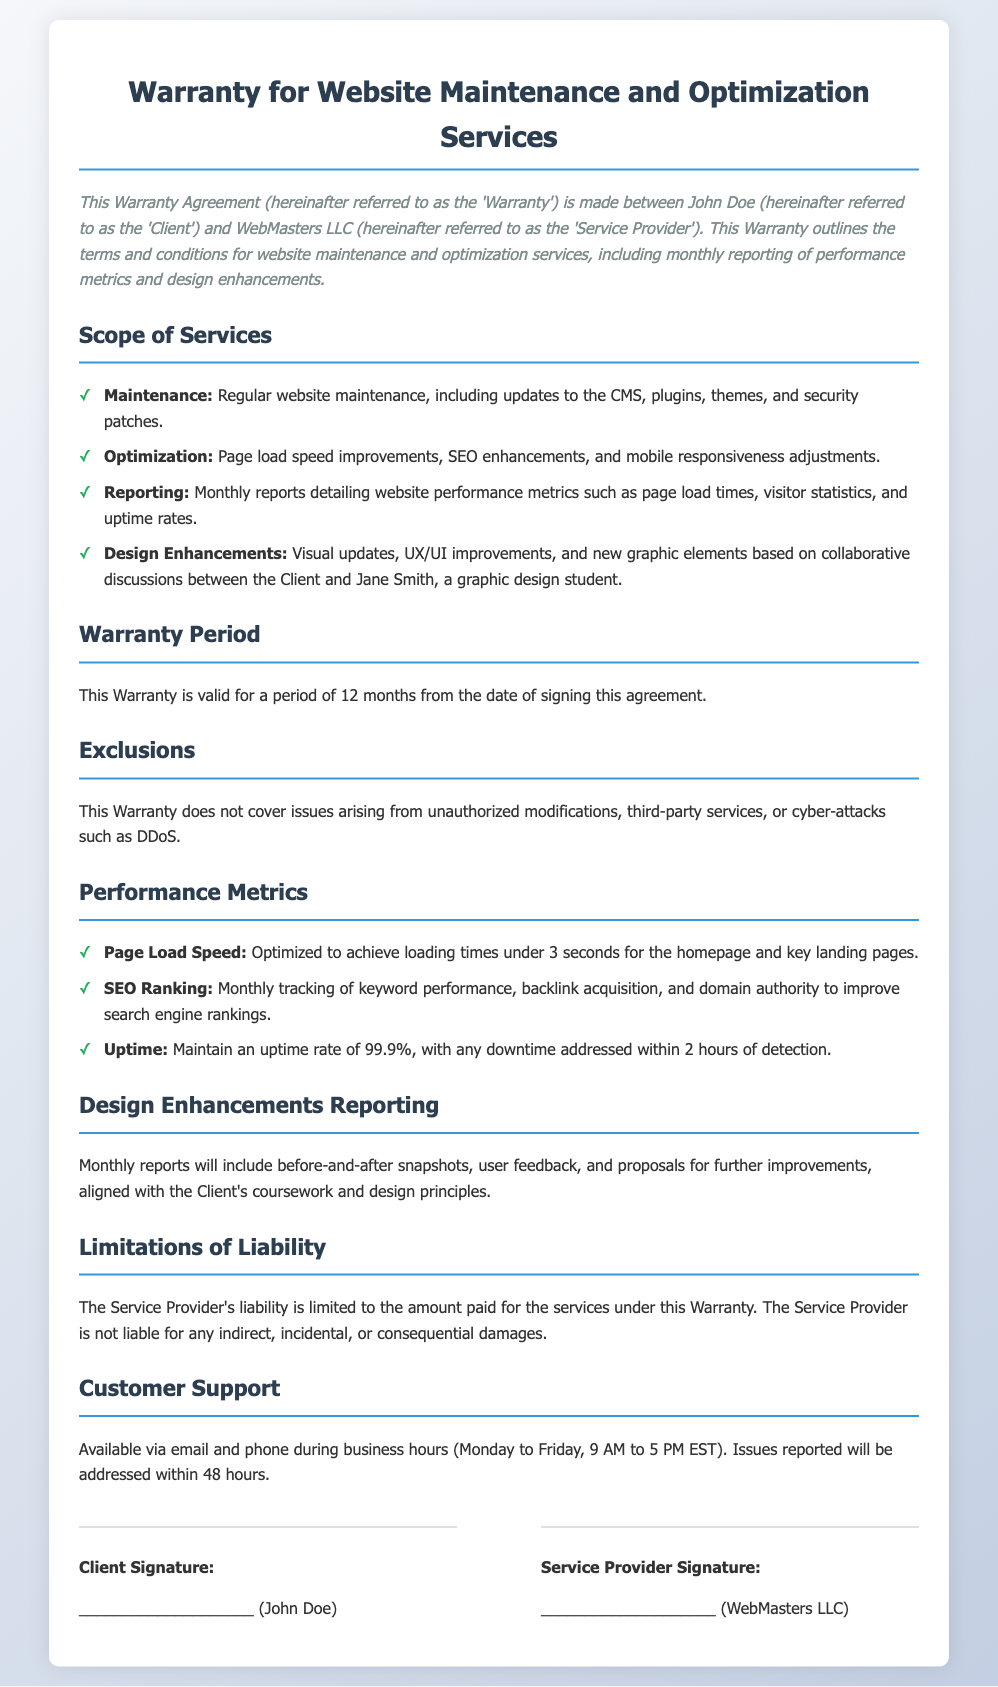What is the name of the Client? The Client is specifically named in the document as John Doe.
Answer: John Doe What is the name of the Service Provider? The Service Provider is referred to as WebMasters LLC in the document.
Answer: WebMasters LLC What is the duration of the Warranty? The duration of the Warranty is specified as 12 months from the signing date.
Answer: 12 months What is the uptime percentage the Service Provider aims to maintain? The document states the desired uptime rate is 99.9%.
Answer: 99.9% What is not covered by the Warranty? The document lists exclusions such as unauthorized modifications and cyber-attacks.
Answer: Unauthorized modifications How often will performance metrics be reported? The performance metrics are to be reported on a monthly basis as stated in the document.
Answer: Monthly What is the maximum loading time targeted for the homepage? The targeted page load speed for the homepage is mentioned as under 3 seconds.
Answer: Under 3 seconds What kind of support is available to the Client? Support is available via email and phone during business hours.
Answer: Email and phone What will the monthly reports include regarding design enhancements? The reports will include before-and-after snapshots, user feedback, and proposals for improvements.
Answer: Before-and-after snapshots 